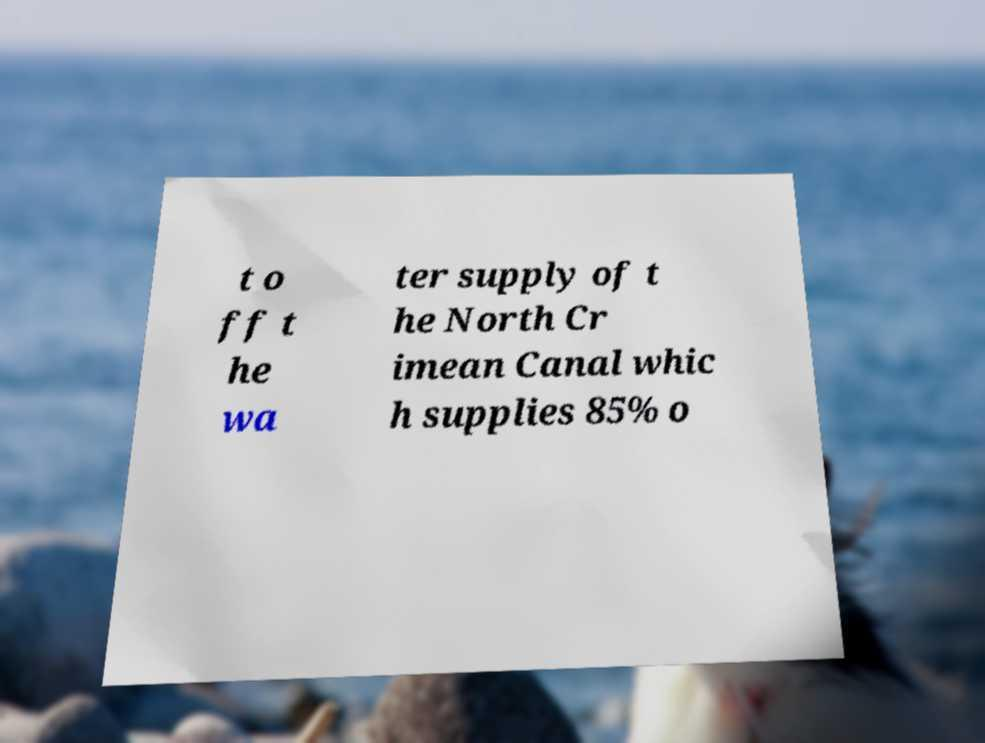Please identify and transcribe the text found in this image. t o ff t he wa ter supply of t he North Cr imean Canal whic h supplies 85% o 